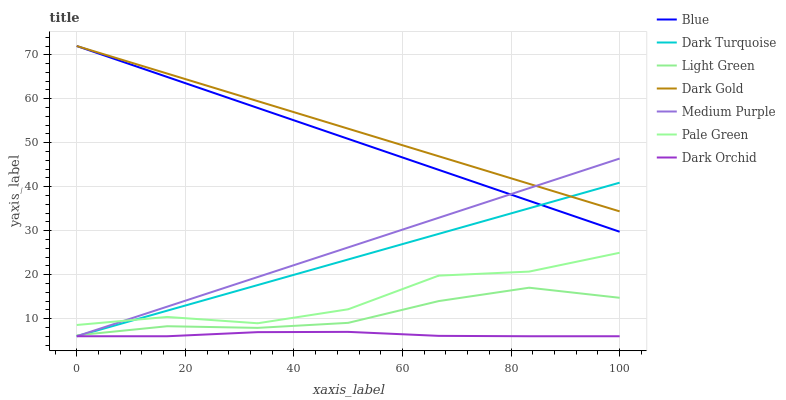Does Dark Orchid have the minimum area under the curve?
Answer yes or no. Yes. Does Dark Gold have the maximum area under the curve?
Answer yes or no. Yes. Does Dark Turquoise have the minimum area under the curve?
Answer yes or no. No. Does Dark Turquoise have the maximum area under the curve?
Answer yes or no. No. Is Medium Purple the smoothest?
Answer yes or no. Yes. Is Pale Green the roughest?
Answer yes or no. Yes. Is Dark Gold the smoothest?
Answer yes or no. No. Is Dark Gold the roughest?
Answer yes or no. No. Does Dark Turquoise have the lowest value?
Answer yes or no. Yes. Does Dark Gold have the lowest value?
Answer yes or no. No. Does Dark Gold have the highest value?
Answer yes or no. Yes. Does Dark Turquoise have the highest value?
Answer yes or no. No. Is Light Green less than Dark Gold?
Answer yes or no. Yes. Is Dark Gold greater than Light Green?
Answer yes or no. Yes. Does Medium Purple intersect Light Green?
Answer yes or no. Yes. Is Medium Purple less than Light Green?
Answer yes or no. No. Is Medium Purple greater than Light Green?
Answer yes or no. No. Does Light Green intersect Dark Gold?
Answer yes or no. No. 